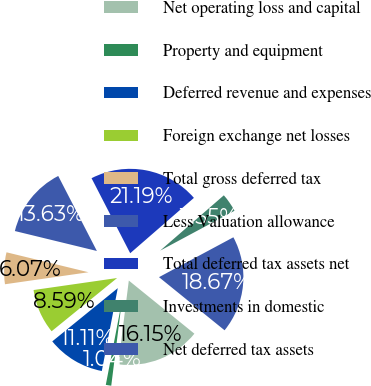Convert chart. <chart><loc_0><loc_0><loc_500><loc_500><pie_chart><fcel>Net operating loss and capital<fcel>Property and equipment<fcel>Deferred revenue and expenses<fcel>Foreign exchange net losses<fcel>Total gross deferred tax<fcel>Less Valuation allowance<fcel>Total deferred tax assets net<fcel>Investments in domestic<fcel>Net deferred tax assets<nl><fcel>16.15%<fcel>1.04%<fcel>11.11%<fcel>8.59%<fcel>6.07%<fcel>13.63%<fcel>21.19%<fcel>3.55%<fcel>18.67%<nl></chart> 